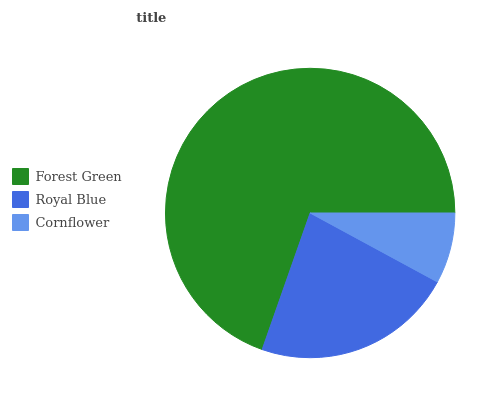Is Cornflower the minimum?
Answer yes or no. Yes. Is Forest Green the maximum?
Answer yes or no. Yes. Is Royal Blue the minimum?
Answer yes or no. No. Is Royal Blue the maximum?
Answer yes or no. No. Is Forest Green greater than Royal Blue?
Answer yes or no. Yes. Is Royal Blue less than Forest Green?
Answer yes or no. Yes. Is Royal Blue greater than Forest Green?
Answer yes or no. No. Is Forest Green less than Royal Blue?
Answer yes or no. No. Is Royal Blue the high median?
Answer yes or no. Yes. Is Royal Blue the low median?
Answer yes or no. Yes. Is Forest Green the high median?
Answer yes or no. No. Is Forest Green the low median?
Answer yes or no. No. 